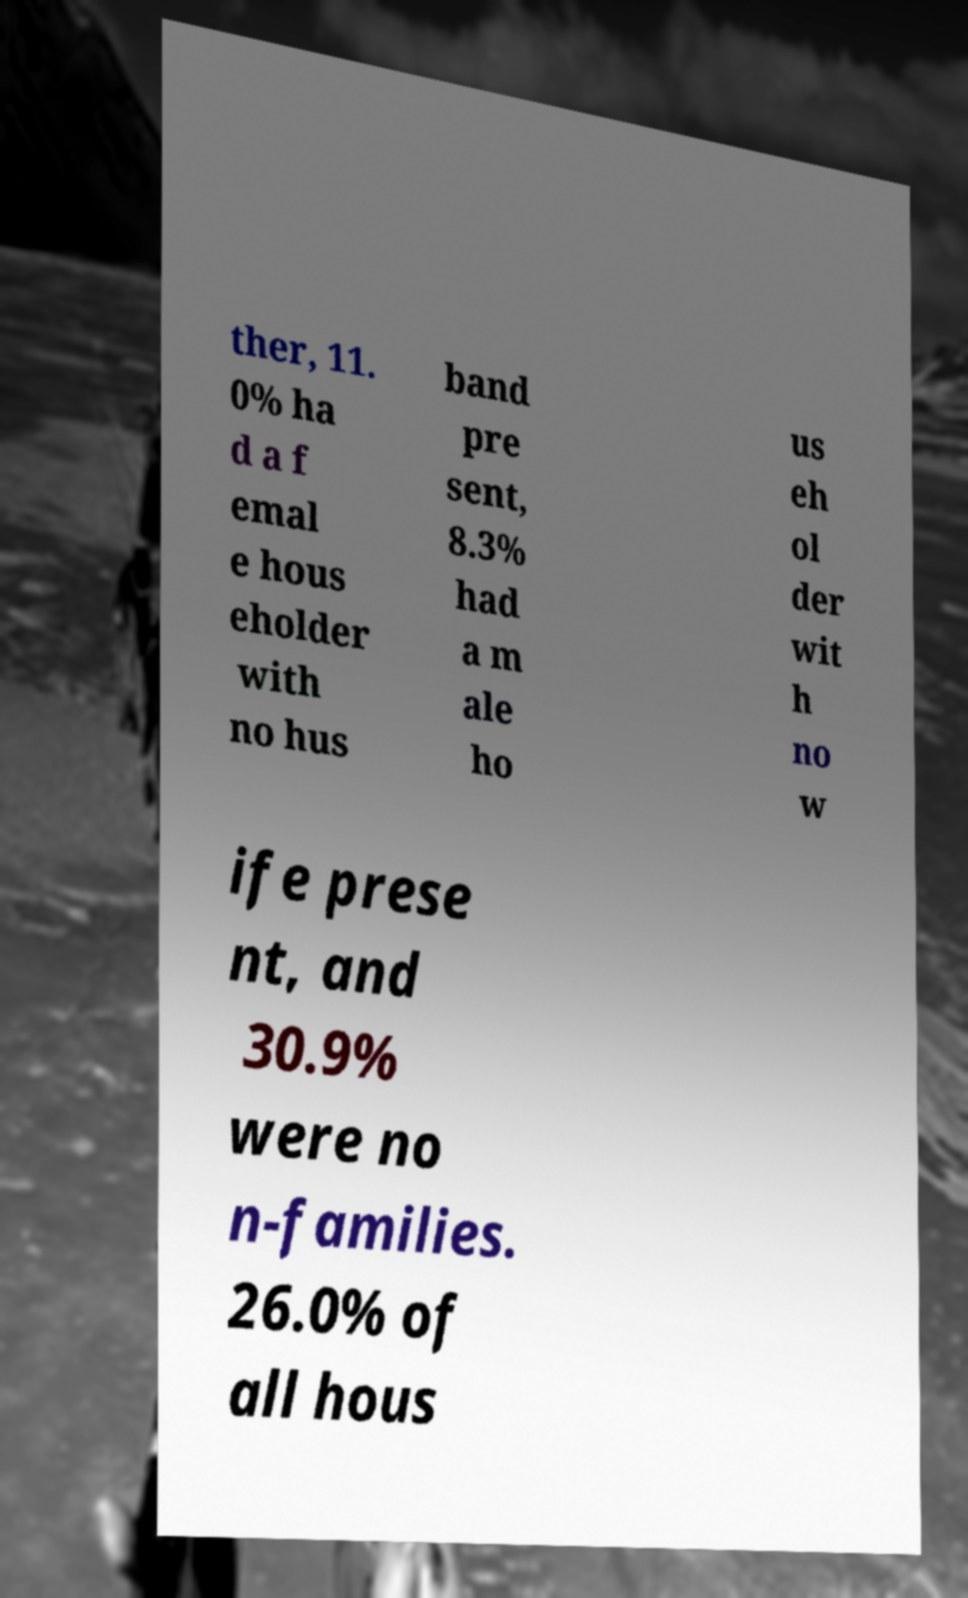What messages or text are displayed in this image? I need them in a readable, typed format. ther, 11. 0% ha d a f emal e hous eholder with no hus band pre sent, 8.3% had a m ale ho us eh ol der wit h no w ife prese nt, and 30.9% were no n-families. 26.0% of all hous 